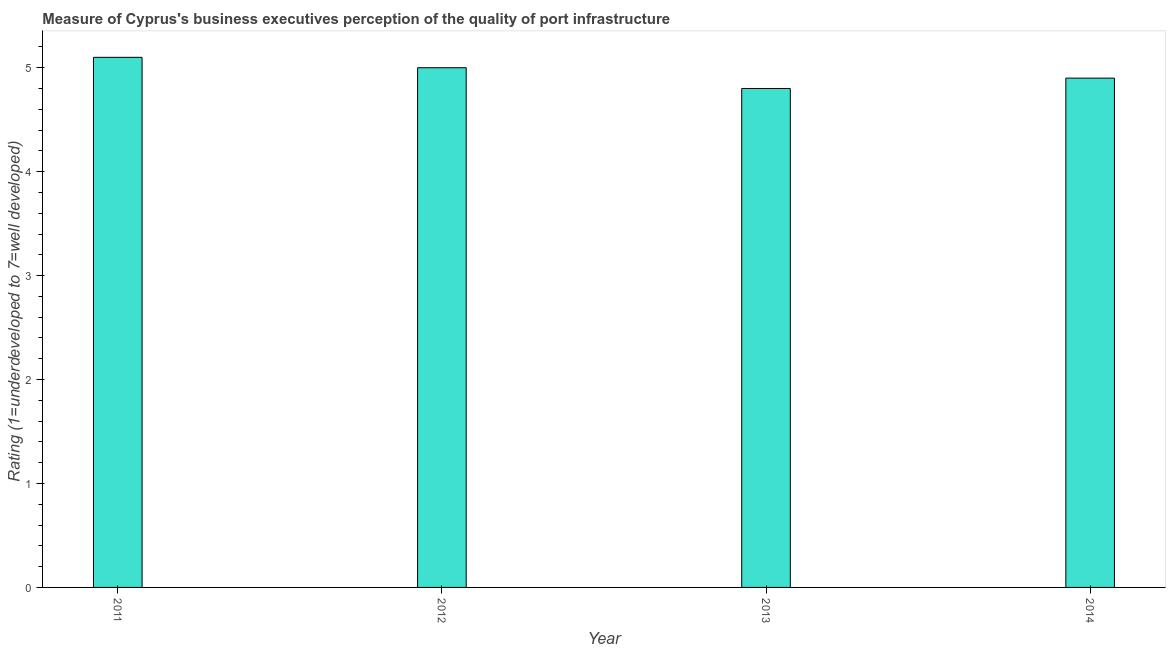Does the graph contain any zero values?
Provide a succinct answer. No. Does the graph contain grids?
Offer a terse response. No. What is the title of the graph?
Give a very brief answer. Measure of Cyprus's business executives perception of the quality of port infrastructure. What is the label or title of the Y-axis?
Make the answer very short. Rating (1=underdeveloped to 7=well developed) . What is the rating measuring quality of port infrastructure in 2012?
Ensure brevity in your answer.  5. Across all years, what is the maximum rating measuring quality of port infrastructure?
Ensure brevity in your answer.  5.1. Across all years, what is the minimum rating measuring quality of port infrastructure?
Provide a short and direct response. 4.8. In which year was the rating measuring quality of port infrastructure maximum?
Make the answer very short. 2011. What is the sum of the rating measuring quality of port infrastructure?
Provide a succinct answer. 19.8. What is the average rating measuring quality of port infrastructure per year?
Provide a succinct answer. 4.95. What is the median rating measuring quality of port infrastructure?
Keep it short and to the point. 4.95. In how many years, is the rating measuring quality of port infrastructure greater than 2.4 ?
Provide a succinct answer. 4. Do a majority of the years between 2014 and 2011 (inclusive) have rating measuring quality of port infrastructure greater than 5 ?
Provide a succinct answer. Yes. What is the ratio of the rating measuring quality of port infrastructure in 2012 to that in 2013?
Give a very brief answer. 1.04. Is the difference between the rating measuring quality of port infrastructure in 2012 and 2014 greater than the difference between any two years?
Offer a terse response. No. What is the difference between the highest and the second highest rating measuring quality of port infrastructure?
Provide a short and direct response. 0.1. In how many years, is the rating measuring quality of port infrastructure greater than the average rating measuring quality of port infrastructure taken over all years?
Your answer should be very brief. 2. How many years are there in the graph?
Provide a short and direct response. 4. What is the difference between two consecutive major ticks on the Y-axis?
Your answer should be very brief. 1. What is the Rating (1=underdeveloped to 7=well developed)  of 2014?
Offer a terse response. 4.9. What is the difference between the Rating (1=underdeveloped to 7=well developed)  in 2012 and 2013?
Make the answer very short. 0.2. What is the difference between the Rating (1=underdeveloped to 7=well developed)  in 2013 and 2014?
Provide a short and direct response. -0.1. What is the ratio of the Rating (1=underdeveloped to 7=well developed)  in 2011 to that in 2012?
Make the answer very short. 1.02. What is the ratio of the Rating (1=underdeveloped to 7=well developed)  in 2011 to that in 2013?
Ensure brevity in your answer.  1.06. What is the ratio of the Rating (1=underdeveloped to 7=well developed)  in 2011 to that in 2014?
Your response must be concise. 1.04. What is the ratio of the Rating (1=underdeveloped to 7=well developed)  in 2012 to that in 2013?
Your answer should be compact. 1.04. What is the ratio of the Rating (1=underdeveloped to 7=well developed)  in 2012 to that in 2014?
Your answer should be compact. 1.02. What is the ratio of the Rating (1=underdeveloped to 7=well developed)  in 2013 to that in 2014?
Offer a very short reply. 0.98. 